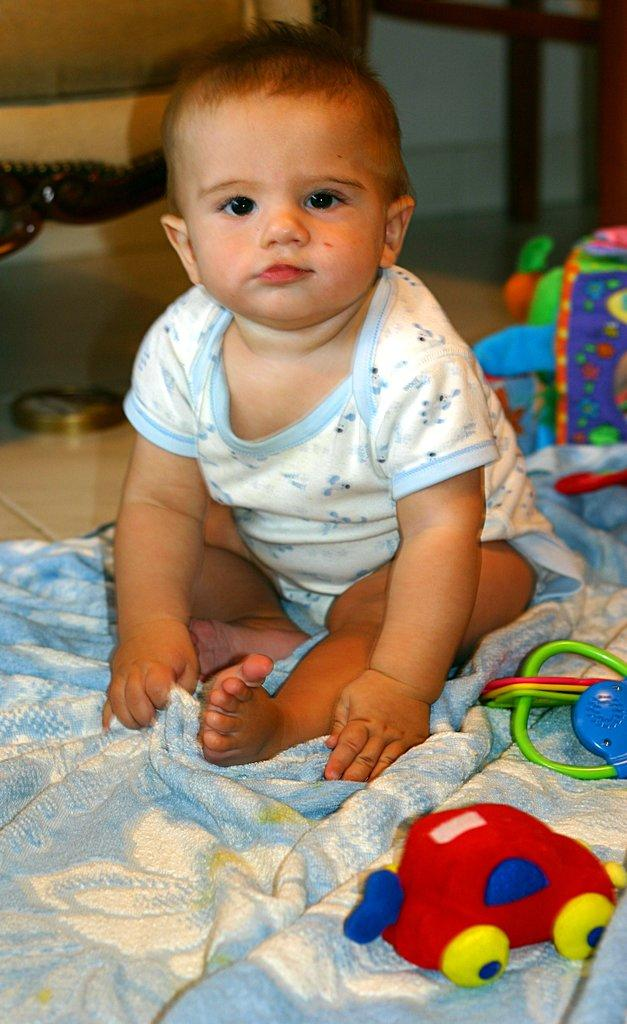What objects can be seen in the image? There are toys in the image. Who is present in the image? There is a child in the image. What is the child sitting or lying on? The child is on a cloth. What can be seen in the background of the image? There is a wall in the background of the image. What type of engine is visible in the image? There is no engine present in the image. What kind of agreement is the child making with the toys in the image? There is no indication of an agreement between the child and the toys in the image. 